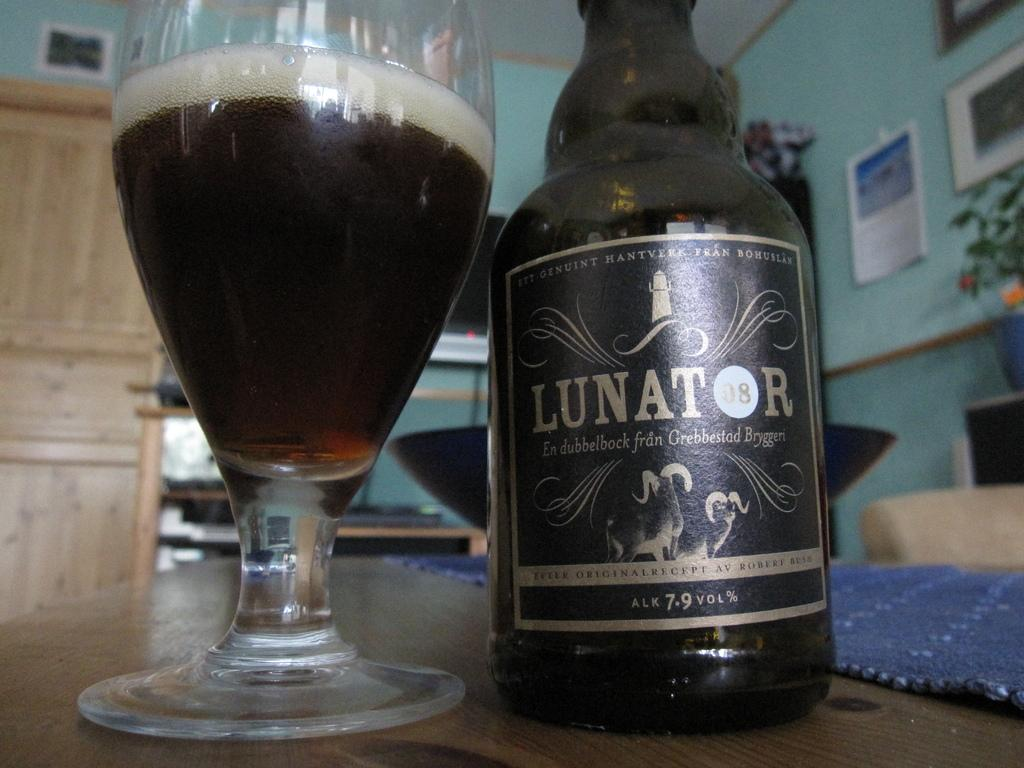Provide a one-sentence caption for the provided image. "LUNATOR" is on the label of a black bottle. 